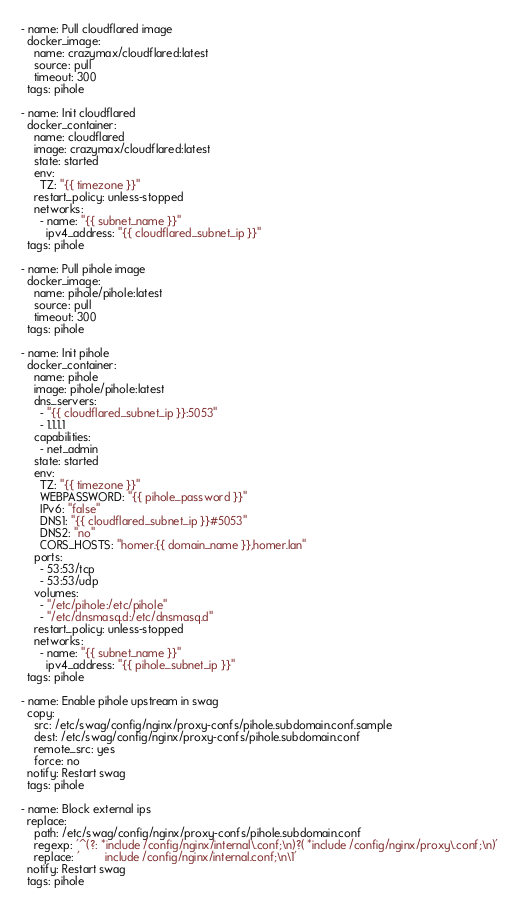Convert code to text. <code><loc_0><loc_0><loc_500><loc_500><_YAML_>- name: Pull cloudflared image
  docker_image:
    name: crazymax/cloudflared:latest
    source: pull
    timeout: 300
  tags: pihole

- name: Init cloudflared
  docker_container:
    name: cloudflared
    image: crazymax/cloudflared:latest
    state: started
    env:
      TZ: "{{ timezone }}"
    restart_policy: unless-stopped
    networks:
      - name: "{{ subnet_name }}"
        ipv4_address: "{{ cloudflared_subnet_ip }}"
  tags: pihole

- name: Pull pihole image
  docker_image:
    name: pihole/pihole:latest
    source: pull
    timeout: 300
  tags: pihole

- name: Init pihole
  docker_container:
    name: pihole
    image: pihole/pihole:latest
    dns_servers:
      - "{{ cloudflared_subnet_ip }}:5053"
      - 1.1.1.1
    capabilities:
      - net_admin
    state: started
    env:
      TZ: "{{ timezone }}"
      WEBPASSWORD: "{{ pihole_password }}"
      IPv6: "false"
      DNS1: "{{ cloudflared_subnet_ip }}#5053"
      DNS2: "no"
      CORS_HOSTS: "homer.{{ domain_name }},homer.lan"
    ports:
      - 53:53/tcp
      - 53:53/udp
    volumes:
      - "/etc/pihole:/etc/pihole"
      - "/etc/dnsmasq.d:/etc/dnsmasq.d"
    restart_policy: unless-stopped
    networks:
      - name: "{{ subnet_name }}"
        ipv4_address: "{{ pihole_subnet_ip }}"
  tags: pihole

- name: Enable pihole upstream in swag
  copy:
    src: /etc/swag/config/nginx/proxy-confs/pihole.subdomain.conf.sample
    dest: /etc/swag/config/nginx/proxy-confs/pihole.subdomain.conf
    remote_src: yes
    force: no
  notify: Restart swag
  tags: pihole

- name: Block external ips
  replace:
    path: /etc/swag/config/nginx/proxy-confs/pihole.subdomain.conf
    regexp: '^(?: *include /config/nginx/internal\.conf;\n)?( *include /config/nginx/proxy\.conf;\n)'
    replace: '        include /config/nginx/internal.conf;\n\1'
  notify: Restart swag
  tags: pihole
</code> 